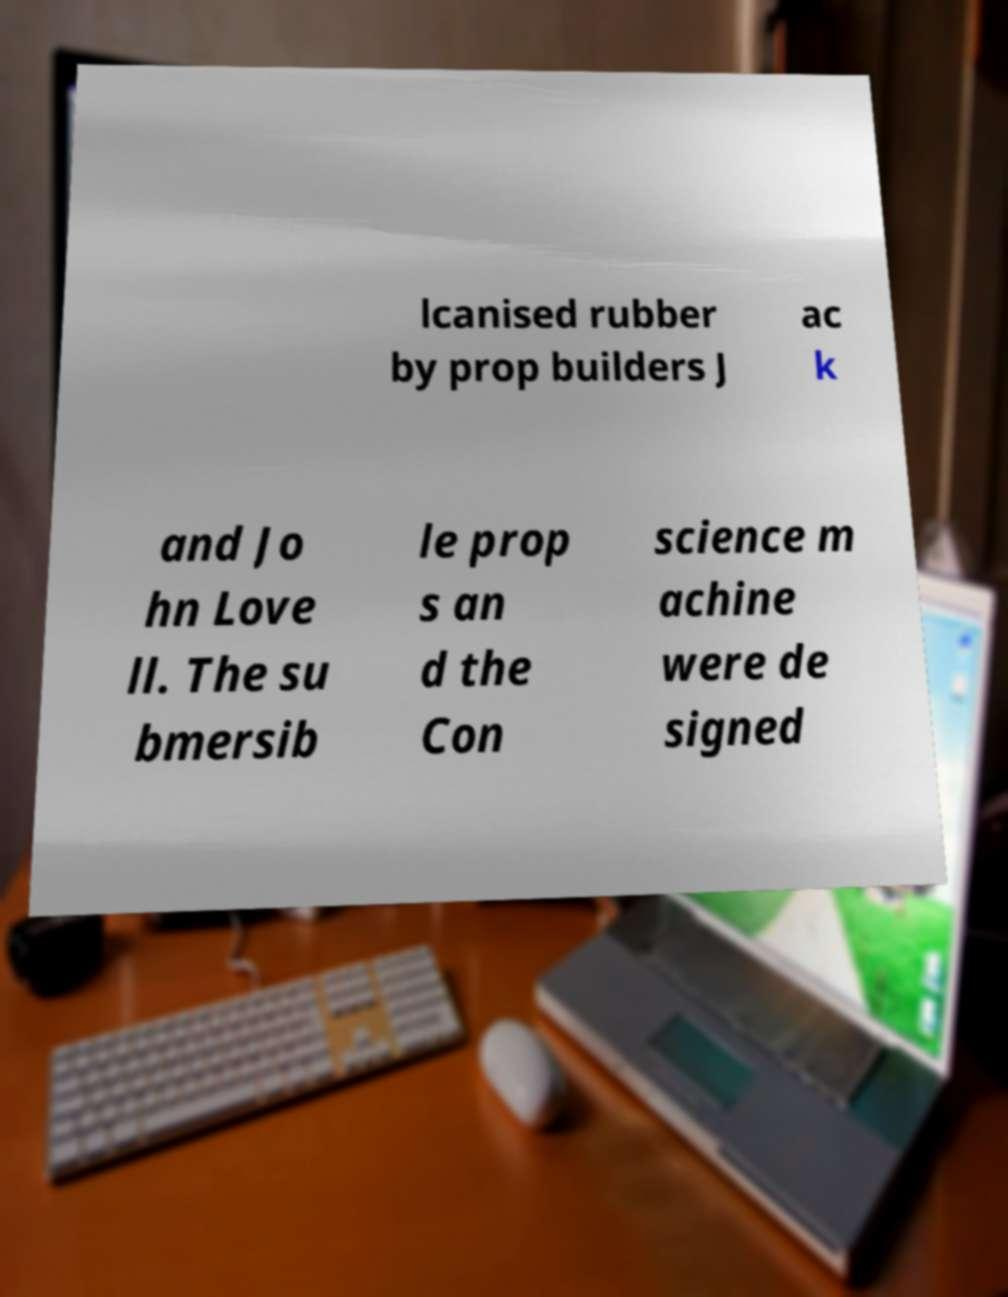Could you extract and type out the text from this image? lcanised rubber by prop builders J ac k and Jo hn Love ll. The su bmersib le prop s an d the Con science m achine were de signed 